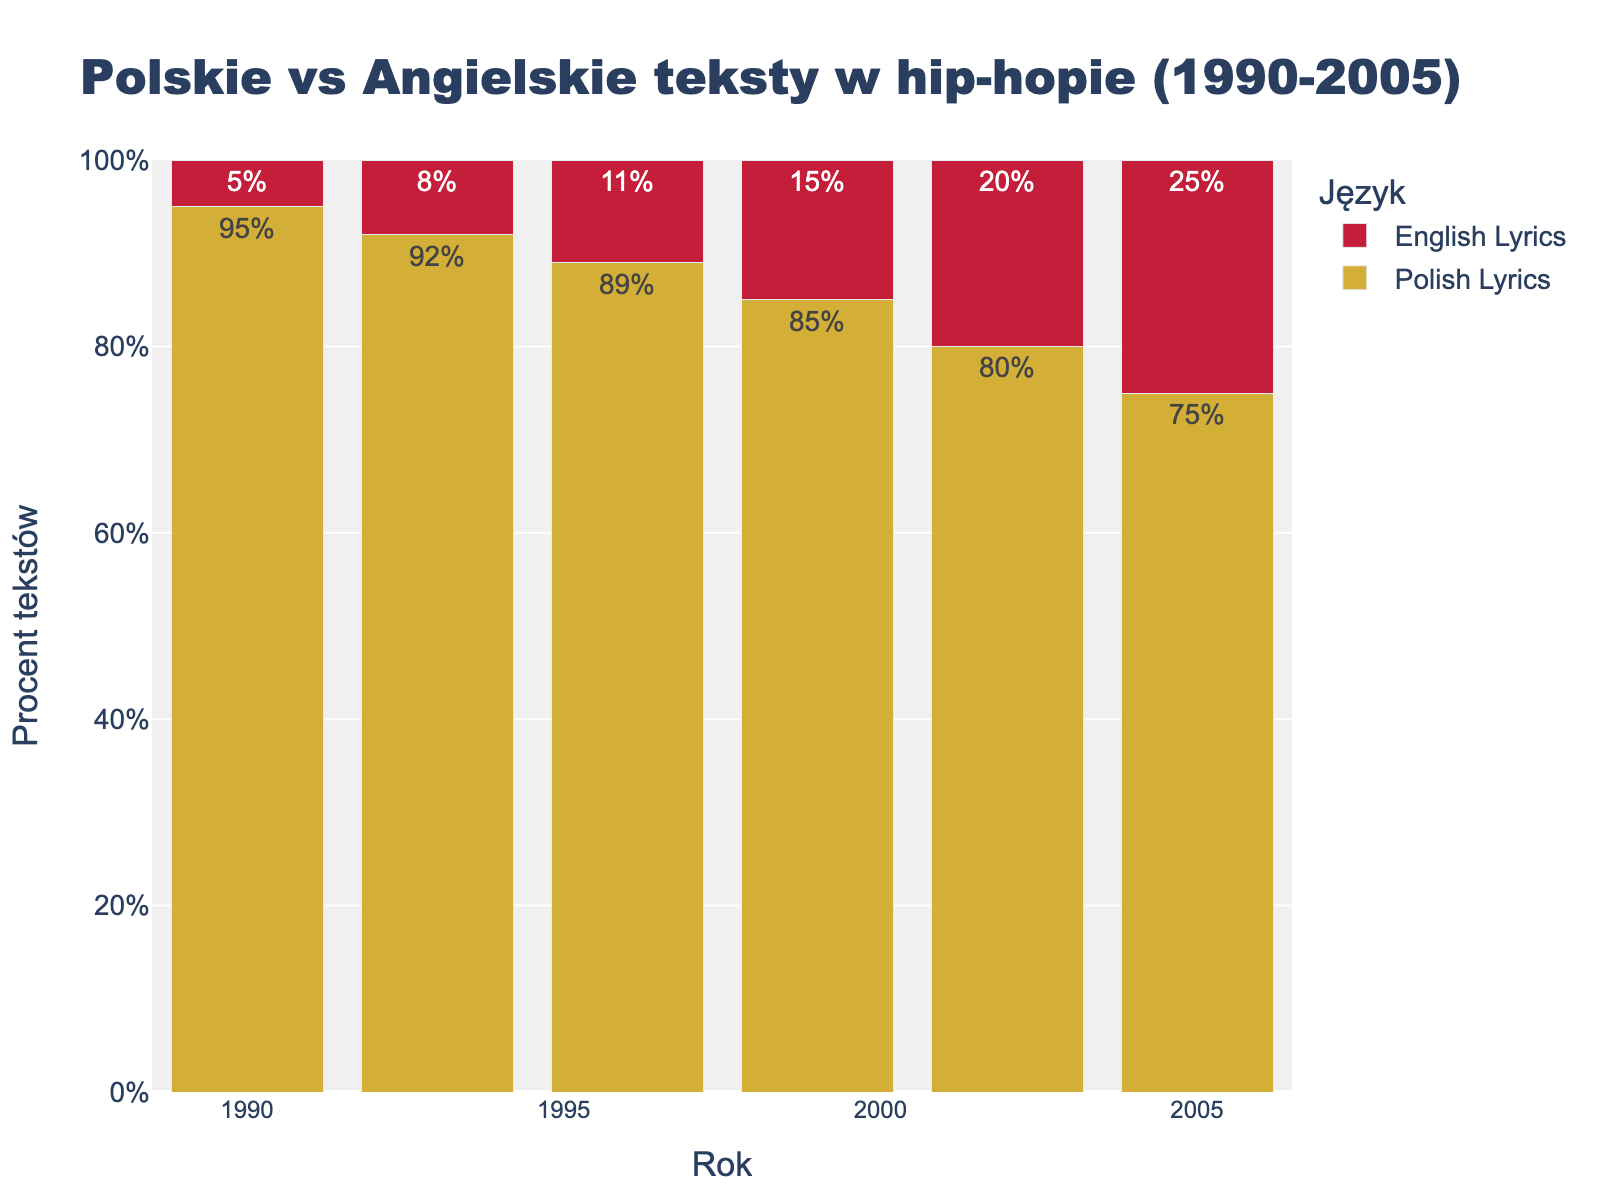What is the percentage of Polish lyrics in the year 2002? Find the bar for the year 2002 and check its label for Polish Lyrics. The label indicates 80%.
Answer: 80% In which year did English lyrics reach 25%? Check the bars for English Lyrics and find the one with a label showing 25%. The year corresponding to this bar is 2005.
Answer: 2005 How did the percentage of Polish lyrics change from 1990 to 1996? In 1990, Polish Lyrics were at 95%. By 1996, they had dropped to 89%. The change is calculated as 95% - 89% = 6%.
Answer: Decreased by 6% What is the average percentage of English lyrics over the given years? Add the percentages of English Lyrics from each year (5 + 8 + 11 + 15 + 20 + 25 = 84), then divide by the number of years (84/6 = 14)
Answer: 14% Which year shows the highest percentage of Polish lyrics? Compare all the bars for Polish Lyrics. The highest percentage is 95% in the year 1990.
Answer: 1990 How many years have seen English lyrics percentages above 10%? Check the English Lyrics bars above 10%. The years are 1996, 1999, 2002, and 2005. This includes 4 years.
Answer: 4 What is the difference in the percentage of English lyrics between 1990 and 2005? In 1990, English Lyrics were at 5%. In 2005, they were 25%. The difference is calculated as 25% - 5% = 20%.
Answer: 20% In which year do Polish lyrics drop below 90% for the first time? Check the bars for Polish Lyrics. The first instance below 90% is in 1996, where the percentage is 89%.
Answer: 1996 Compare the percentage change in English lyrics from 1999 to 2005. In 1999, English Lyrics were at 15%. By 2005, they were 25%. The percentage change is (25% - 15%) / 15% * 100% = 66.67%.
Answer: 66.67% How did the total percentage of English lyrics change from 1996 to 2005? In 1996, the percentage was 11%. By 2005, it was 25%. The change is calculated as a difference: 25% - 11% = 14%.
Answer: Increased by 14% 